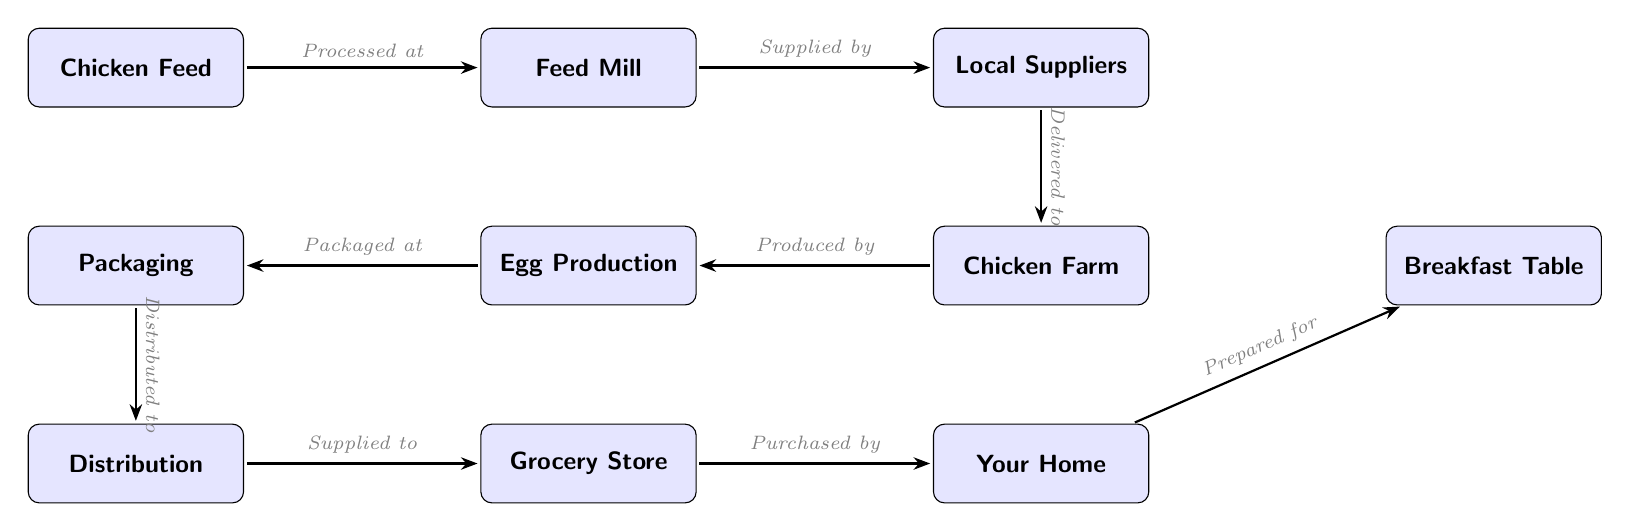How many nodes are in the diagram? The diagram consists of 9 nodes which represent the different stages of the poultry and egg supply chain, from chicken feed to breakfast table.
Answer: 9 What does the arrow from 'chicken feed' to 'feed mill' indicate? The arrow indicates that chicken feed is processed at the feed mill, highlighting a direct relationship in the supply chain where feed is converted into usable form for chickens.
Answer: Processed at Which node comes after 'packaging' in the flow? The node that comes after 'packaging' is 'distribution', indicating the sequence in which products move along the supply chain.
Answer: Distribution What is the last step before reaching the 'breakfast table'? The last step before reaching the 'breakfast table' is 'prepared for', indicating the action taken to make food ready for consumption after purchase.
Answer: Prepared for Who purchases from the 'grocery store'? 'Home' is the entity that purchases from the grocery store, representing the consumer level in the supply chain.
Answer: Home What is the relationship between 'eggs' and 'packaging'? The relationship indicates that eggs are packaged at a specific stage in the supply chain, emphasizing the importance of proper packaging for distribution.
Answer: Packaged at Which node serves as a supplier in the diagram? 'Local suppliers' serves as the supplier in the diagram, providing necessary resources to the chicken farm.
Answer: Local Suppliers How is 'distribution' connected to 'grocery store'? 'Distribution' is connected to 'grocery store' indicating that products from the chicken and egg supply chain are delivered to grocery stores for sale.
Answer: Supplied to What is produced by the 'chicken farm'? The 'chicken farm' produces 'eggs', highlighting the role of farms in the poultry and egg supply chain.
Answer: Eggs 